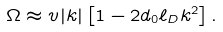Convert formula to latex. <formula><loc_0><loc_0><loc_500><loc_500>\Omega \approx v | k | \left [ 1 - 2 d _ { 0 } \ell _ { D } k ^ { 2 } \right ] .</formula> 